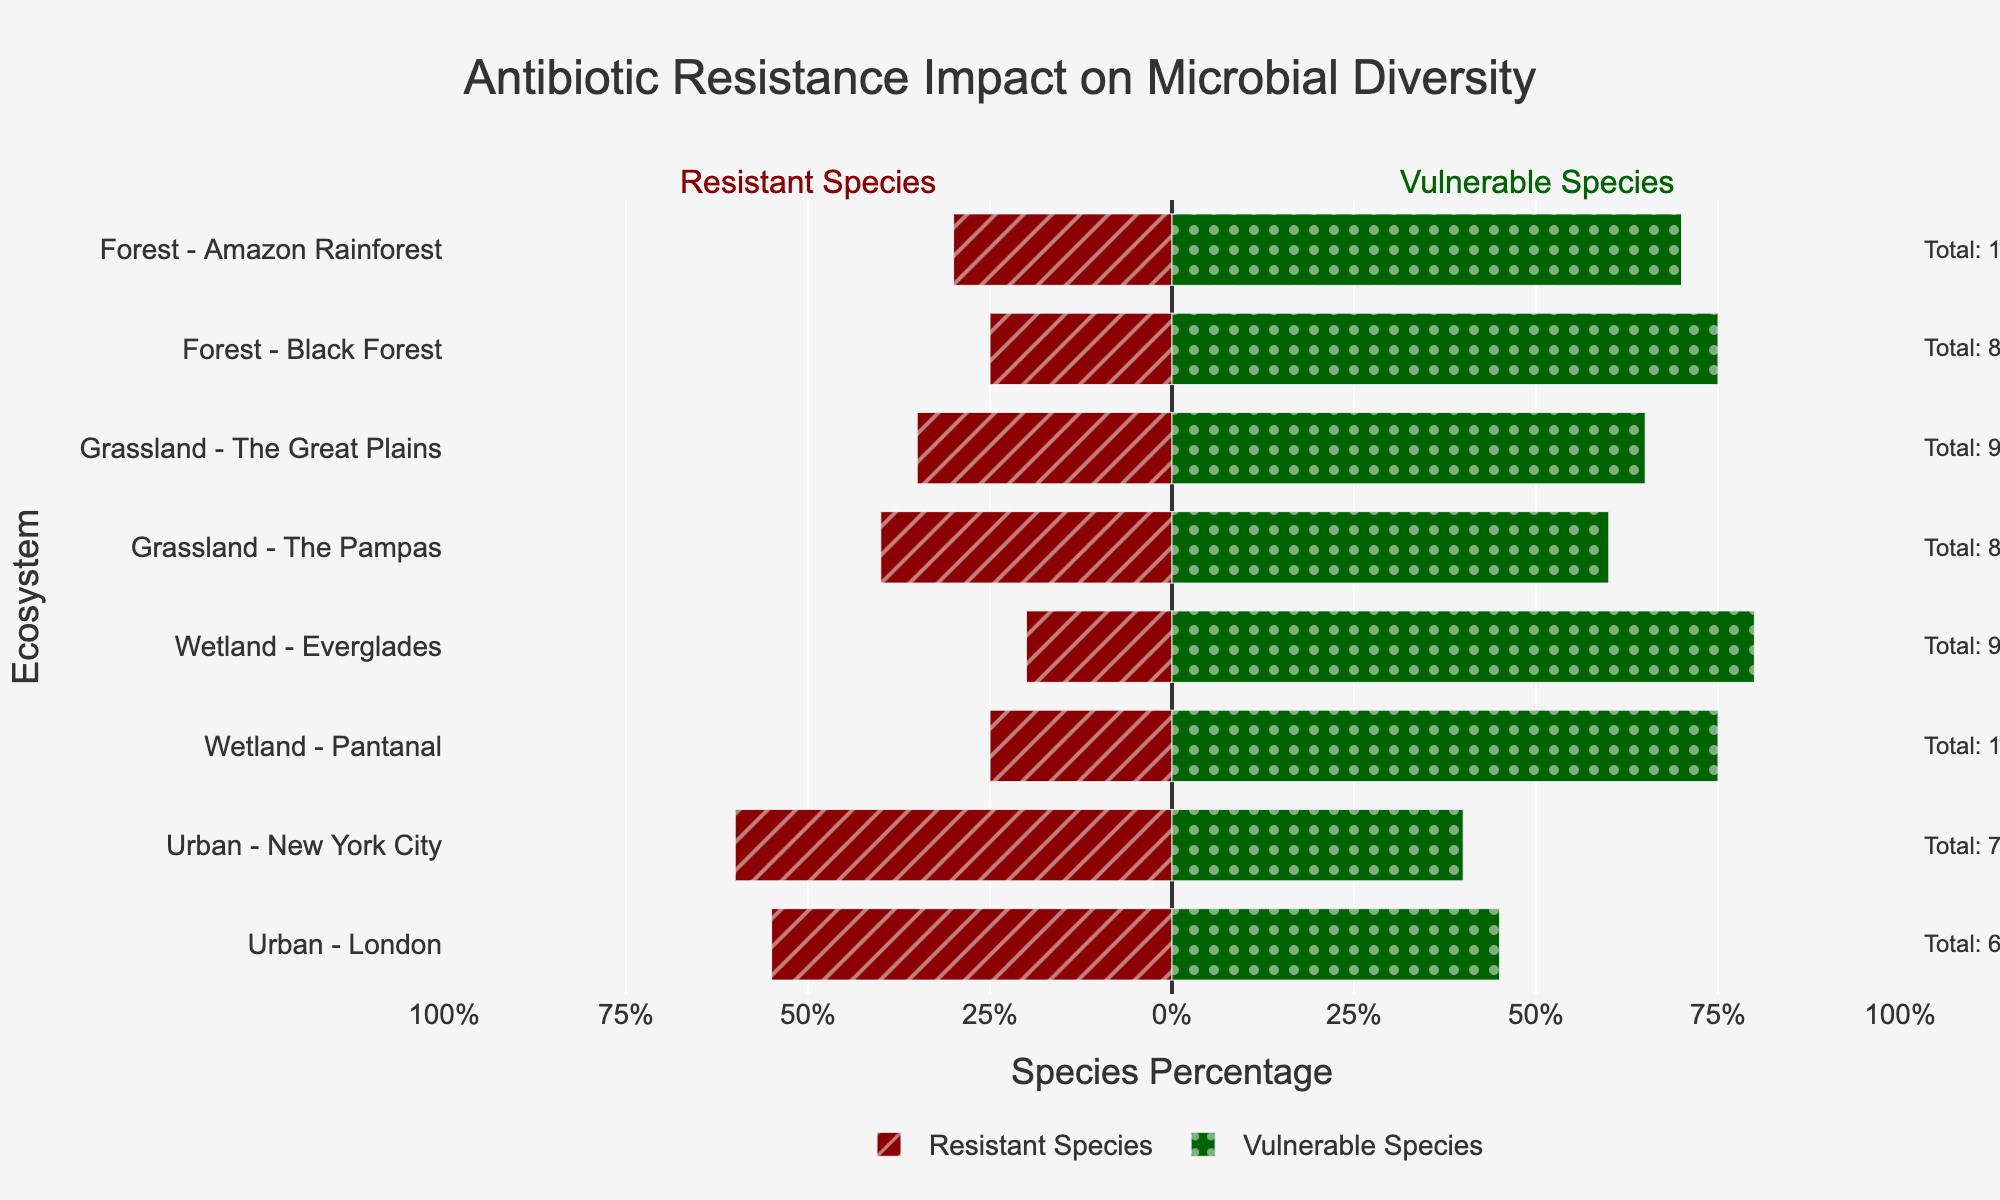Which ecosystem has the highest percentage of resistant species? To determine which ecosystem has the highest percentage of resistant species, we look at the length of the red bars that extend to the left. The Urban - New York City ecosystem has the longest red bar at 60%.
Answer: Urban - New York City What is the difference in the percentage of vulnerable species between the Wetland - Everglades and the Forest - Black Forest ecosystems? To find the difference, we look at the green bars' lengths for both ecosystems. Wetland - Everglades shows 80% vulnerable species, and Forest - Black Forest shows 75%. The difference is 80 - 75 = 5%.
Answer: 5% Which ecosystem has a higher total species count, Grassland - The Pampas or Urban - London? According to the annotations, Grassland - The Pampas has a total species count of 85, while Urban - London has 65.
Answer: Grassland - The Pampas Compare the percentage of resistant species between the Forest - Amazon Rainforest and the Grassland - The Great Plains. Which one is higher, and by how much? The Forest - Amazon Rainforest has 30% resistant species, and the Grassland - The Great Plains has 35%. The difference is 35% - 30% = 5%. Grassland - The Great Plains is higher.
Answer: Grassland - The Great Plains by 5% What is the average percentage of vulnerable species across the two urban ecosystems? Urban - New York City has 40% and Urban - London has 45% vulnerable species. The average is (40 + 45)/2 = 42.5%.
Answer: 42.5% Which ecosystem has the smallest percentage of resistant species, and what is that percentage? By looking at the red bars, Wetland - Everglades has the smallest percentage of resistant species at 20%.
Answer: Wetland - Everglades, 20% How does the total species count for the Forest - Amazon Rainforest compare to the Wetland - Pantanal? The annotation indicates that the Forest - Amazon Rainforest has 100 species and Wetland - Pantanal also has 100. Therefore, they are equal in total species count.
Answer: Equal, 100 species each What is the total percentage distribution of species (resistant + vulnerable) in Grassland - The Great Plains? Each ecosystem's total distribution is the sum of resistant and vulnerable percentages. For Grassland - The Great Plains, it's 35% (resistant) + 65% (vulnerable) = 100%.
Answer: 100% 